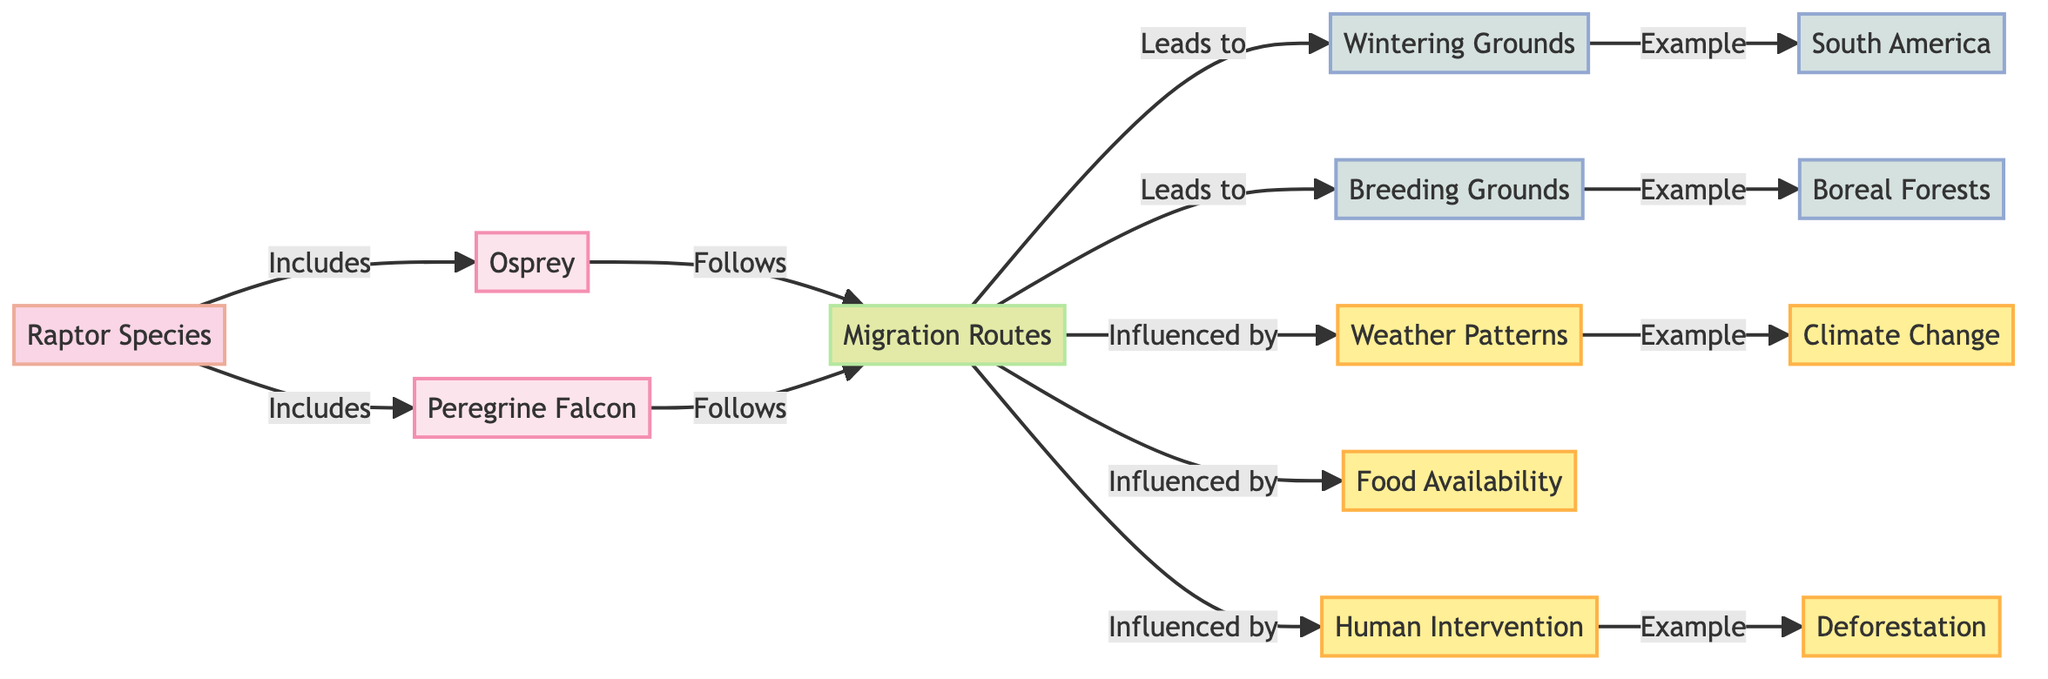What are the two species included in the diagram? The diagram specifies two raptor species: Osprey and Peregrine Falcon, both of which are categorized under the 'Raptor Species' node.
Answer: Osprey and Peregrine Falcon How many factors influence migration routes? The diagram lists four factors that influence the migration routes: Weather Patterns, Food Availability, Human Intervention, and Deforestation. These factors are shown as links stemming from the 'Migration Routes' node.
Answer: Four What do the migration routes lead to? According to the diagram, the migration routes lead to two locations: Wintering Grounds and Breeding Grounds. These are connected directly from the 'Migration Routes' node.
Answer: Wintering Grounds and Breeding Grounds Which location is an example of breeding grounds? The diagram specifies Boreal Forests as an example of breeding grounds, illustrating the relationship between the 'Breeding Grounds' node and the example node.
Answer: Boreal Forests What example is given for wintering grounds? The diagram indicates South America as an example of wintering grounds, showcasing the connection from the 'Wintering Grounds' node to the specific example.
Answer: South America What type of human intervention is mentioned in the diagram? Deforestation is mentioned as an example of human intervention that can impact migration routes, indicating a negative influence on raptor habitats.
Answer: Deforestation How do migration routes relate to food availability? The diagram illustrates that migration routes are influenced by food availability, establishing a connection that indicates raptors choose migration paths based on food resources during their journeys.
Answer: Influenced by What impact does climate change have on migration patterns? Climate change, as shown in the diagram, is highlighted as a critical influencing factor on migration patterns, suggesting that environmental shifts disrupt traditional raptor migration routes.
Answer: Critical factor How many raptor species are represented in the diagram? The diagram represents two raptor species, Osprey and Peregrine Falcon, which are explicitly labeled under the 'Raptor Species' node.
Answer: Two 